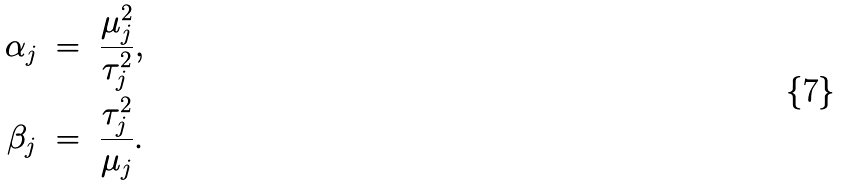<formula> <loc_0><loc_0><loc_500><loc_500>\alpha _ { j } & \ = \ \frac { \mu _ { j } ^ { 2 } } { \tau _ { j } ^ { 2 } } , \\ \beta _ { j } & \ = \ \frac { \tau _ { j } ^ { 2 } } { \mu _ { j } } .</formula> 